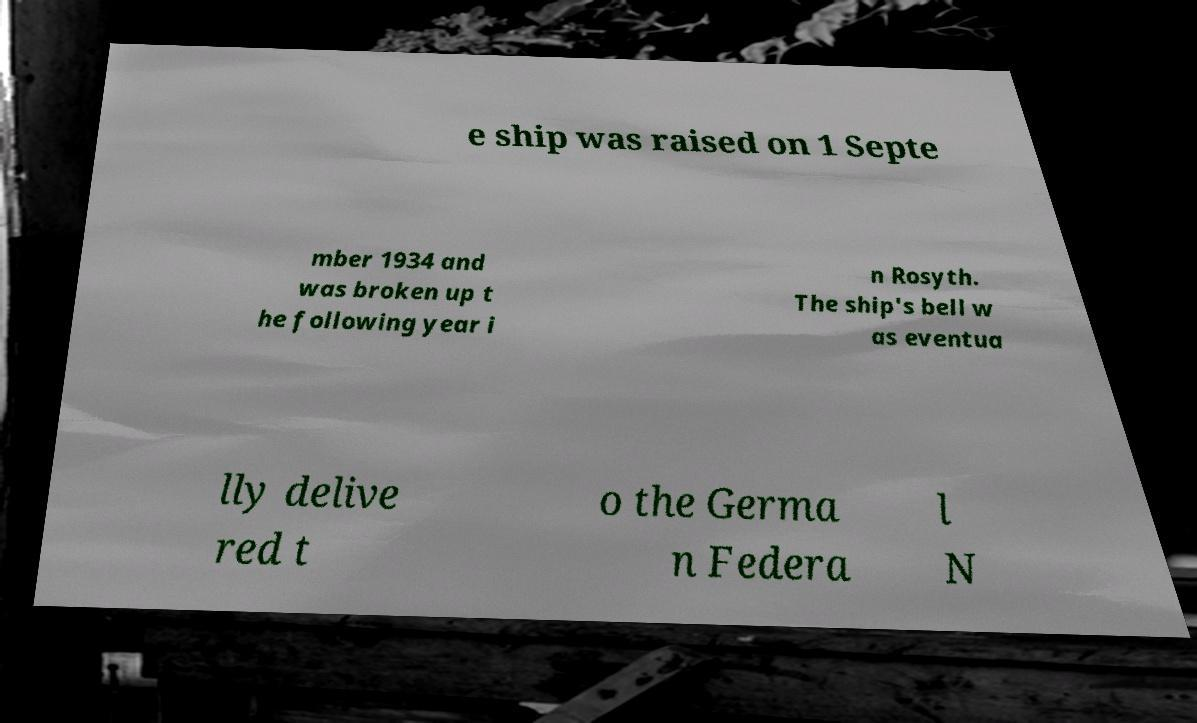For documentation purposes, I need the text within this image transcribed. Could you provide that? e ship was raised on 1 Septe mber 1934 and was broken up t he following year i n Rosyth. The ship's bell w as eventua lly delive red t o the Germa n Federa l N 